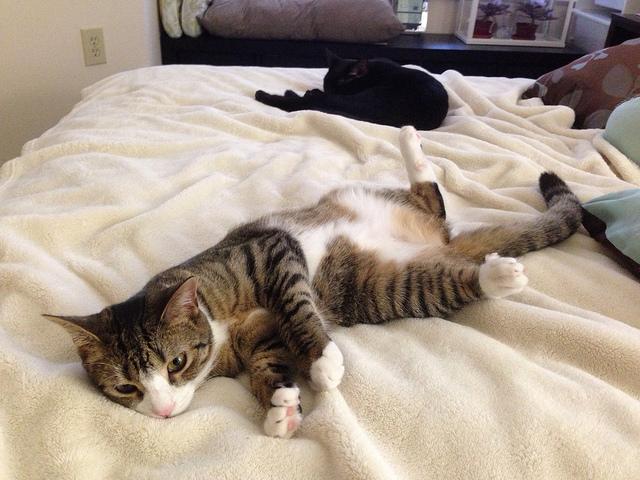Is the cat standing on the bed?
Be succinct. No. What are the two animals on the bed?
Be succinct. Cats. Are these cats enemies?
Short answer required. No. How old is the cat?
Concise answer only. 1. 